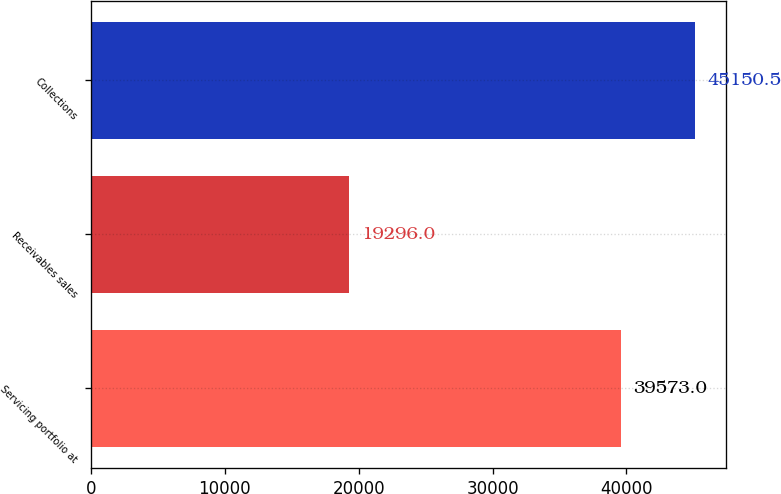Convert chart to OTSL. <chart><loc_0><loc_0><loc_500><loc_500><bar_chart><fcel>Servicing portfolio at<fcel>Receivables sales<fcel>Collections<nl><fcel>39573<fcel>19296<fcel>45150.5<nl></chart> 